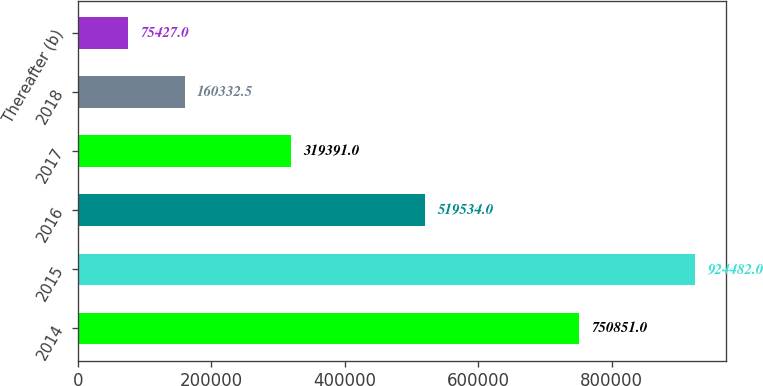Convert chart to OTSL. <chart><loc_0><loc_0><loc_500><loc_500><bar_chart><fcel>2014<fcel>2015<fcel>2016<fcel>2017<fcel>2018<fcel>Thereafter (b)<nl><fcel>750851<fcel>924482<fcel>519534<fcel>319391<fcel>160332<fcel>75427<nl></chart> 